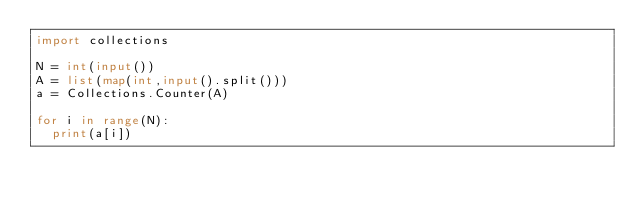Convert code to text. <code><loc_0><loc_0><loc_500><loc_500><_Python_>import collections

N = int(input())
A = list(map(int,input().split()))
a = Collections.Counter(A)

for i in range(N):
  print(a[i])</code> 